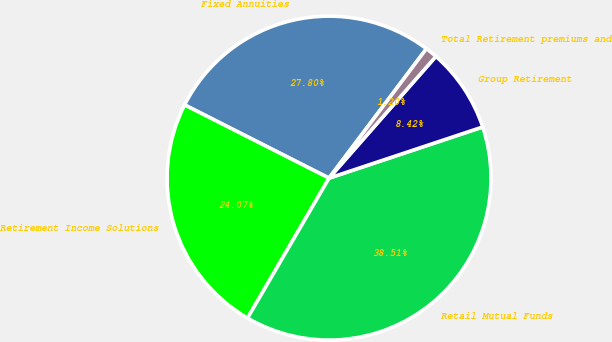<chart> <loc_0><loc_0><loc_500><loc_500><pie_chart><fcel>Fixed Annuities<fcel>Retirement Income Solutions<fcel>Retail Mutual Funds<fcel>Group Retirement<fcel>Total Retirement premiums and<nl><fcel>27.8%<fcel>24.07%<fcel>38.51%<fcel>8.42%<fcel>1.2%<nl></chart> 